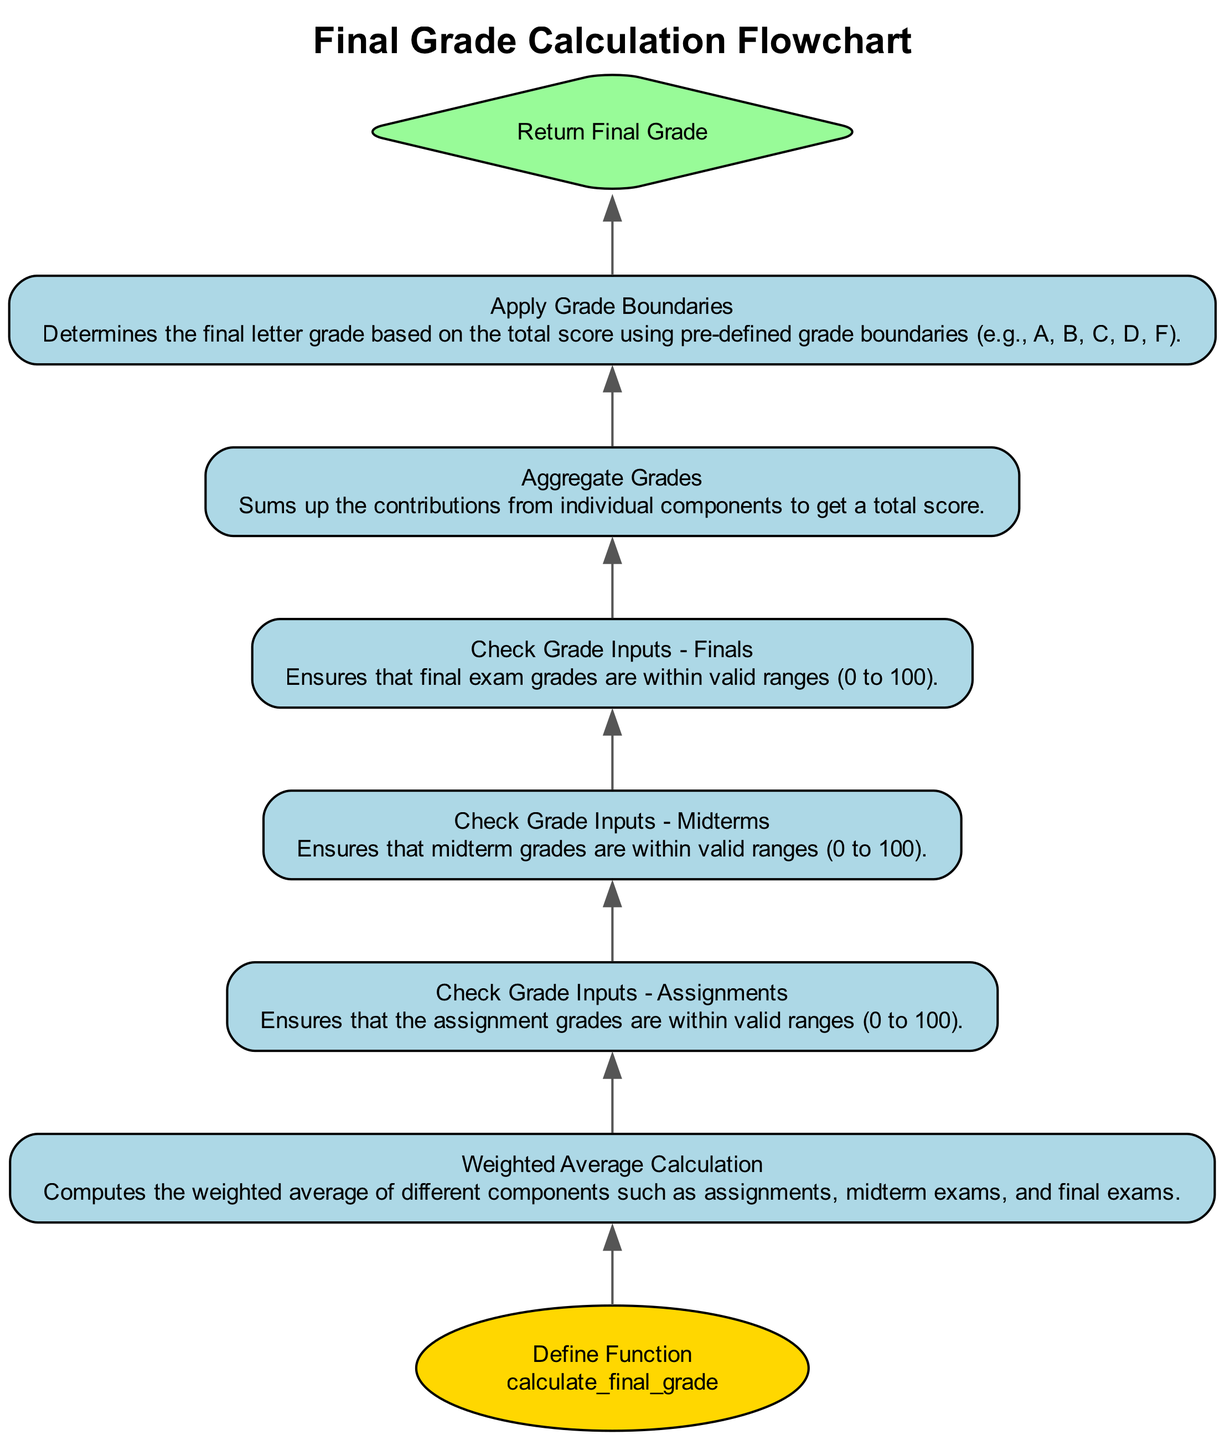What is the first step in the function? The first step in the function is to define the function called calculate_final_grade. This is the initial node in the flowchart.
Answer: Define Function - calculate_final_grade How many input grade checks are there? There are three input grade checks in the flowchart: one for assignments, one for midterms, and one for finals. These checks validate the ranges of the respective grades.
Answer: Three What follows after checking the grade inputs for finals? After checking the grade inputs for finals, the next step is to aggregate grades, which sums up the contributions from individual components.
Answer: Aggregate Grades What is determined after calculating the weighted average? After calculating the weighted average, the next step is to apply grade boundaries, where the total score is converted into a final letter grade.
Answer: Apply Grade Boundaries What is the shape of the final node in the flowchart? The shape of the final node in the flowchart is a diamond, which indicates that it is a decision point, returning the final grade as output.
Answer: Diamond 